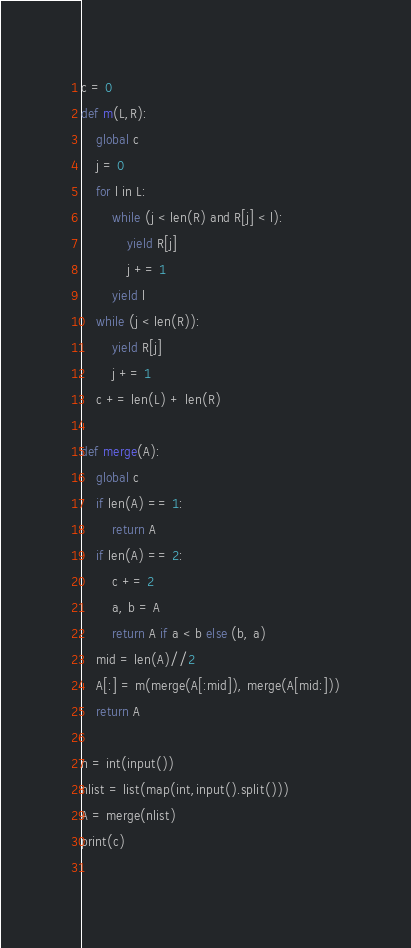Convert code to text. <code><loc_0><loc_0><loc_500><loc_500><_Python_>c = 0
def m(L,R):   
    global c
    j = 0
    for l in L:
        while (j < len(R) and R[j] < l):
            yield R[j]
            j += 1
        yield l
    while (j < len(R)):
        yield R[j]
        j += 1
    c += len(L) + len(R)
    
def merge(A):
    global c
    if len(A) == 1:
        return A
    if len(A) == 2:
        c += 2
        a, b = A
        return A if a < b else (b, a)
    mid = len(A)//2
    A[:] = m(merge(A[:mid]), merge(A[mid:]))
    return A
    
n = int(input())
nlist = list(map(int,input().split()))
A = merge(nlist)  
print(c)
        
</code> 